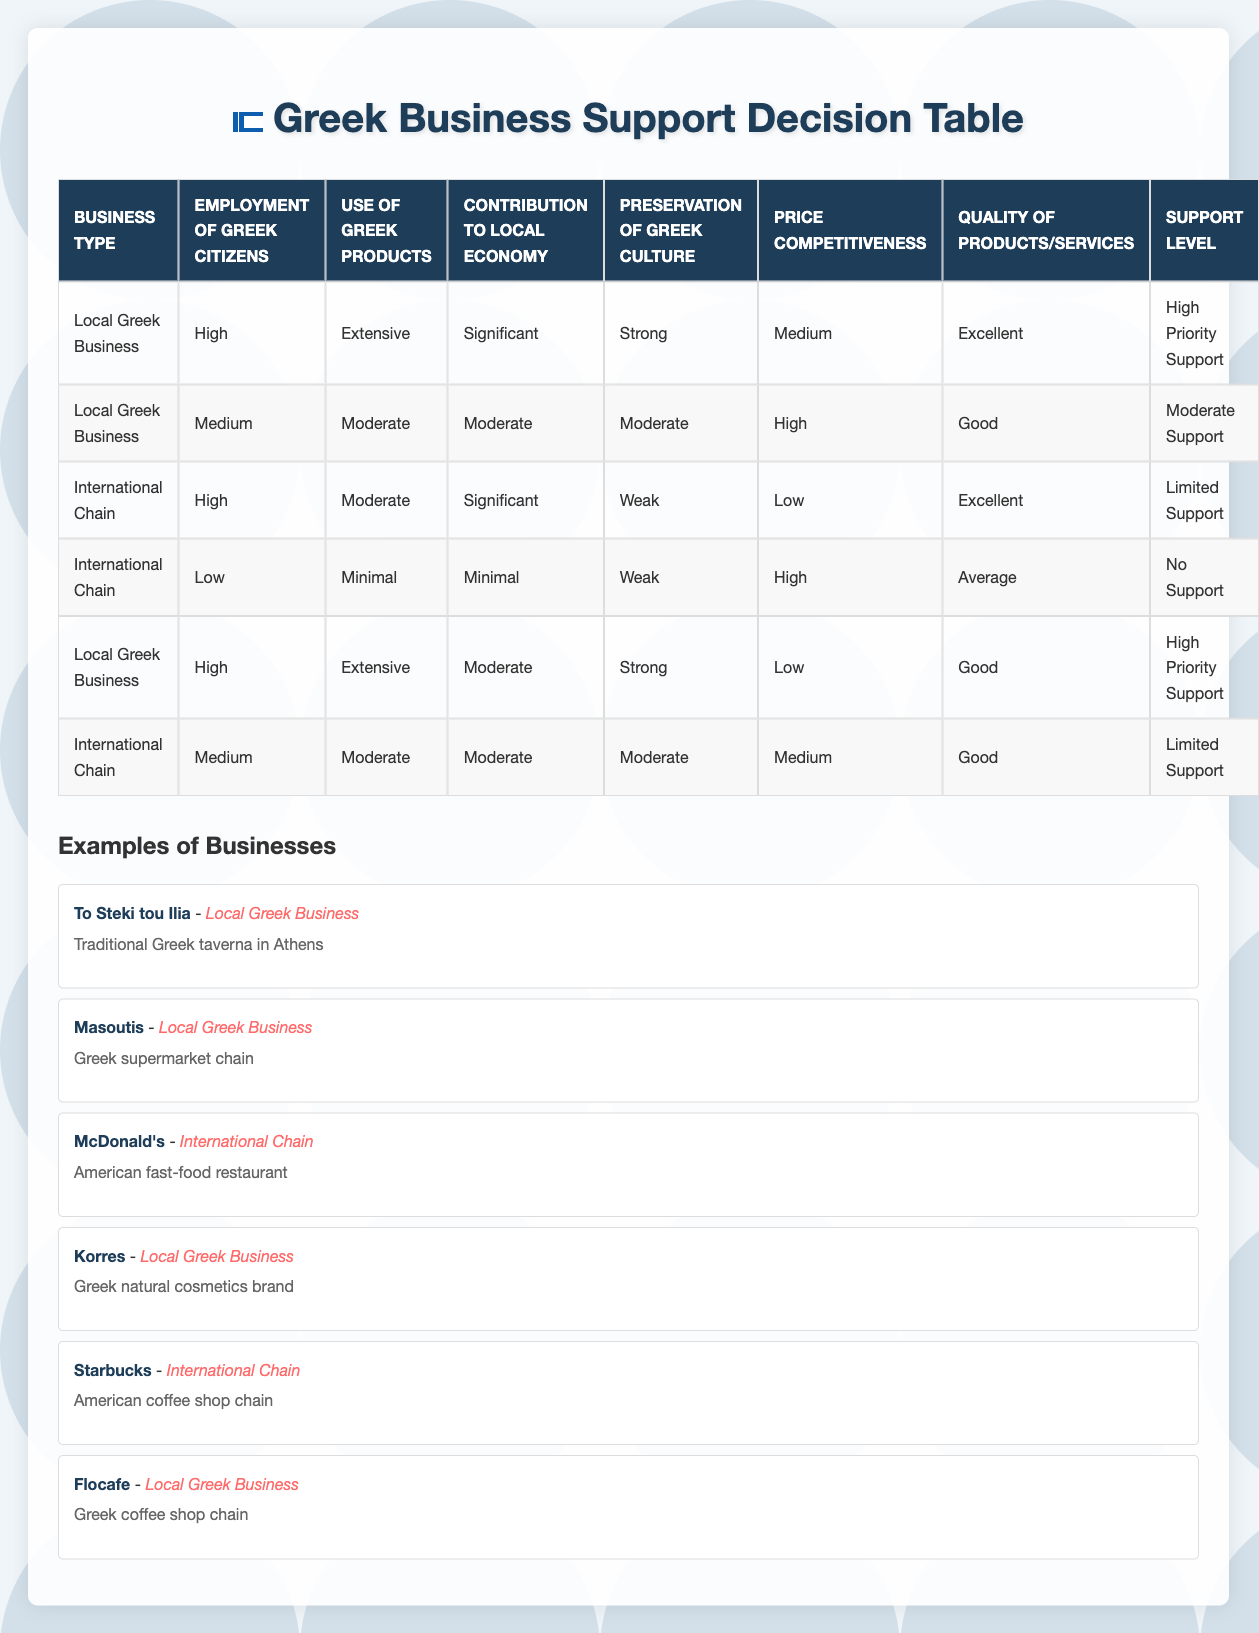What type of business receives High Priority Support? According to the table, both instances of "Local Greek Business" with conditions of "High" employment of Greek citizens and "Extensive" use of Greek products, along with "Significant" contribution to the local economy and "Strong" preservation of Greek culture, receive High Priority Support.
Answer: Local Greek Business Which business has the lowest support level? The business type listed with "International Chain," "Low" employment of Greek citizens, "Minimal" use of Greek products, "Minimal" contribution to the local economy, "Weak" preservation of Greek culture, "High" price competitiveness, and "Average" quality of products/services is given "No Support."
Answer: International Chain How many Local Greek Businesses are in the table? The table lists three instances of Local Greek Businesses: "To Steki tou Ilia," "Masoutis," and "Korres," as well as "Flocafe," making a total of four Local Greek Businesses when all mentions are counted.
Answer: Four Which support level is assigned to International Chains with Medium employment of Greek citizens? The table indicates that an "International Chain" with "Medium" employment of Greek citizens, "Moderate" use of Greek products, "Moderate" contribution to the local economy, "Moderate" preservation of Greek culture, "Medium" price competitiveness, and "Good" quality of products/services is assigned "Limited Support."
Answer: Limited Support What is the average support level for Local Greek Businesses based on the table? Two instances are specified for Local Greek Businesses receiving "High Priority Support" and one receiving "Moderate Support." To find the average, count "High Priority Support" as 2 and "Moderate Support" as 1: (2*3 + 1*1) / 4 = 2.5. Since "Limited Support" and "No Support" are not included in the Local Greek category, the average reflects the higher priority.
Answer: High Priority Support Is there any International Chain with excellent quality and high employment of Greek citizens? According to the table, there is one "International Chain" with "High" employment of Greek citizens and "Excellent" quality, but it has "Moderate" use of Greek products and contributes significantly to the local economy while maintaining a weak preservation of Greek culture, resulting in "Limited Support." Hence, it does exist.
Answer: Yes What is the relationship between the employment of Greek citizens and the support level given to Local Greek Businesses? In the table, Local Greek Businesses with "High" employment consistently receive "High Priority Support," while those with "Medium" employment receive "Moderate Support." No Local Greek Businesses with "Low" employment are documented; therefore, the support level appears higher with increased employment of Greek citizens.
Answer: Higher employment correlates with higher support Are there more Local Greek Businesses or International Chains receiving support? The table displays three Local Greek Businesses listed compared to only two International Chains that receive any form of support, namely "Limited Support." Thus, Local Greek Businesses outnumber International Chains.
Answer: More Local Greek Businesses 